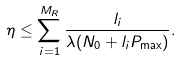<formula> <loc_0><loc_0><loc_500><loc_500>\eta \leq \sum _ { i = 1 } ^ { M _ { R } } \frac { l _ { i } } { \lambda ( N _ { 0 } + l _ { i } P _ { \max } ) } .</formula> 